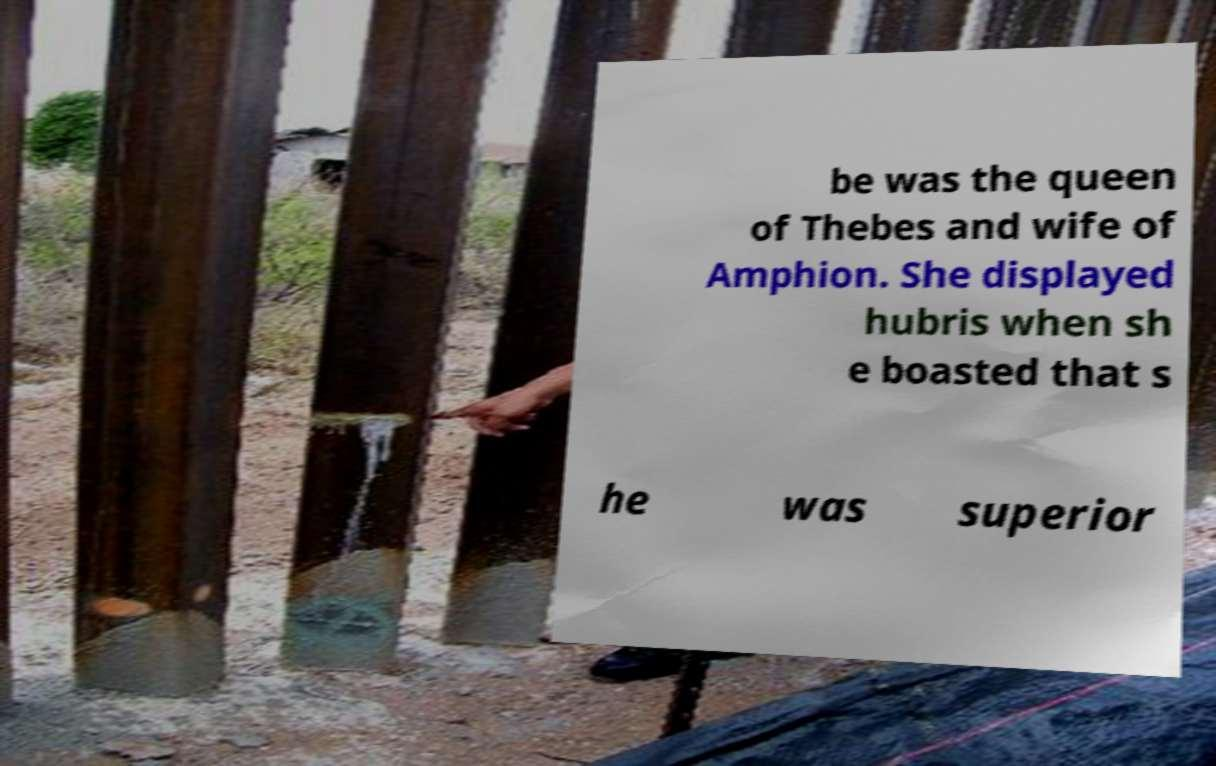There's text embedded in this image that I need extracted. Can you transcribe it verbatim? be was the queen of Thebes and wife of Amphion. She displayed hubris when sh e boasted that s he was superior 